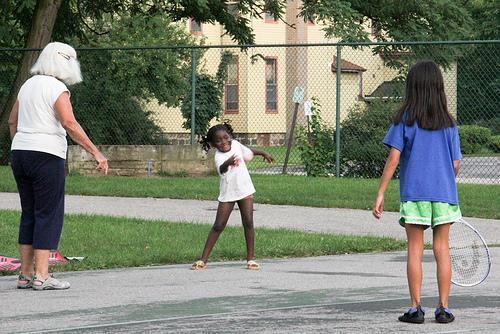How many people are in the picture?
Give a very brief answer. 3. 